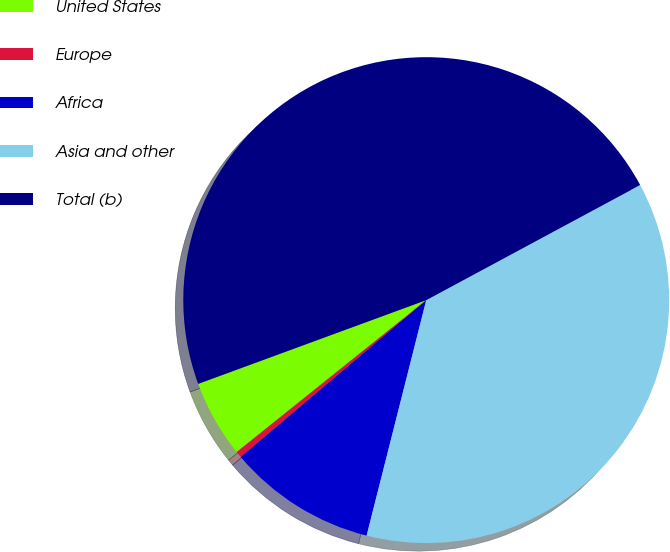Convert chart to OTSL. <chart><loc_0><loc_0><loc_500><loc_500><pie_chart><fcel>United States<fcel>Europe<fcel>Africa<fcel>Asia and other<fcel>Total (b)<nl><fcel>5.15%<fcel>0.42%<fcel>9.88%<fcel>36.8%<fcel>47.74%<nl></chart> 